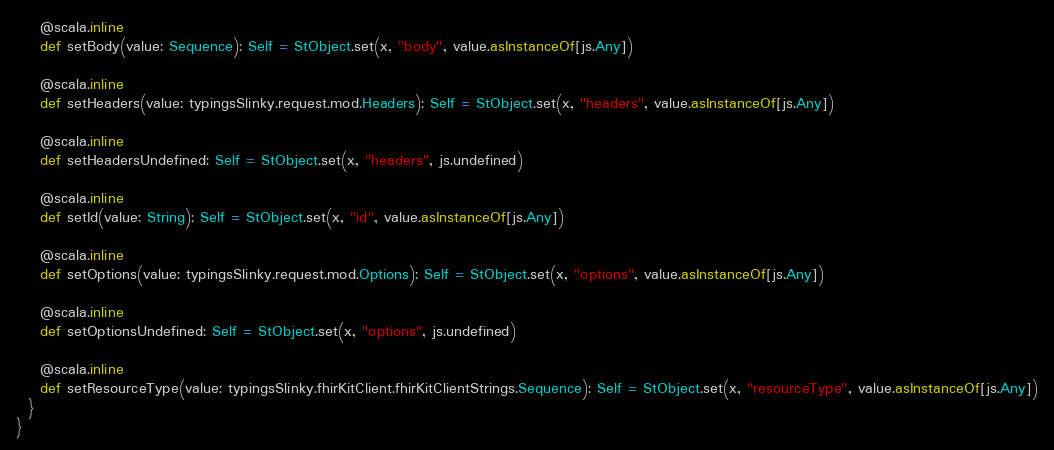Convert code to text. <code><loc_0><loc_0><loc_500><loc_500><_Scala_>    @scala.inline
    def setBody(value: Sequence): Self = StObject.set(x, "body", value.asInstanceOf[js.Any])
    
    @scala.inline
    def setHeaders(value: typingsSlinky.request.mod.Headers): Self = StObject.set(x, "headers", value.asInstanceOf[js.Any])
    
    @scala.inline
    def setHeadersUndefined: Self = StObject.set(x, "headers", js.undefined)
    
    @scala.inline
    def setId(value: String): Self = StObject.set(x, "id", value.asInstanceOf[js.Any])
    
    @scala.inline
    def setOptions(value: typingsSlinky.request.mod.Options): Self = StObject.set(x, "options", value.asInstanceOf[js.Any])
    
    @scala.inline
    def setOptionsUndefined: Self = StObject.set(x, "options", js.undefined)
    
    @scala.inline
    def setResourceType(value: typingsSlinky.fhirKitClient.fhirKitClientStrings.Sequence): Self = StObject.set(x, "resourceType", value.asInstanceOf[js.Any])
  }
}
</code> 